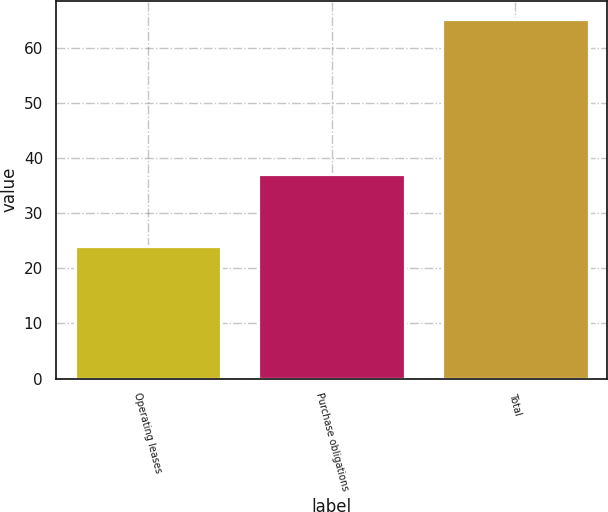Convert chart. <chart><loc_0><loc_0><loc_500><loc_500><bar_chart><fcel>Operating leases<fcel>Purchase obligations<fcel>Total<nl><fcel>24<fcel>37.1<fcel>65.2<nl></chart> 